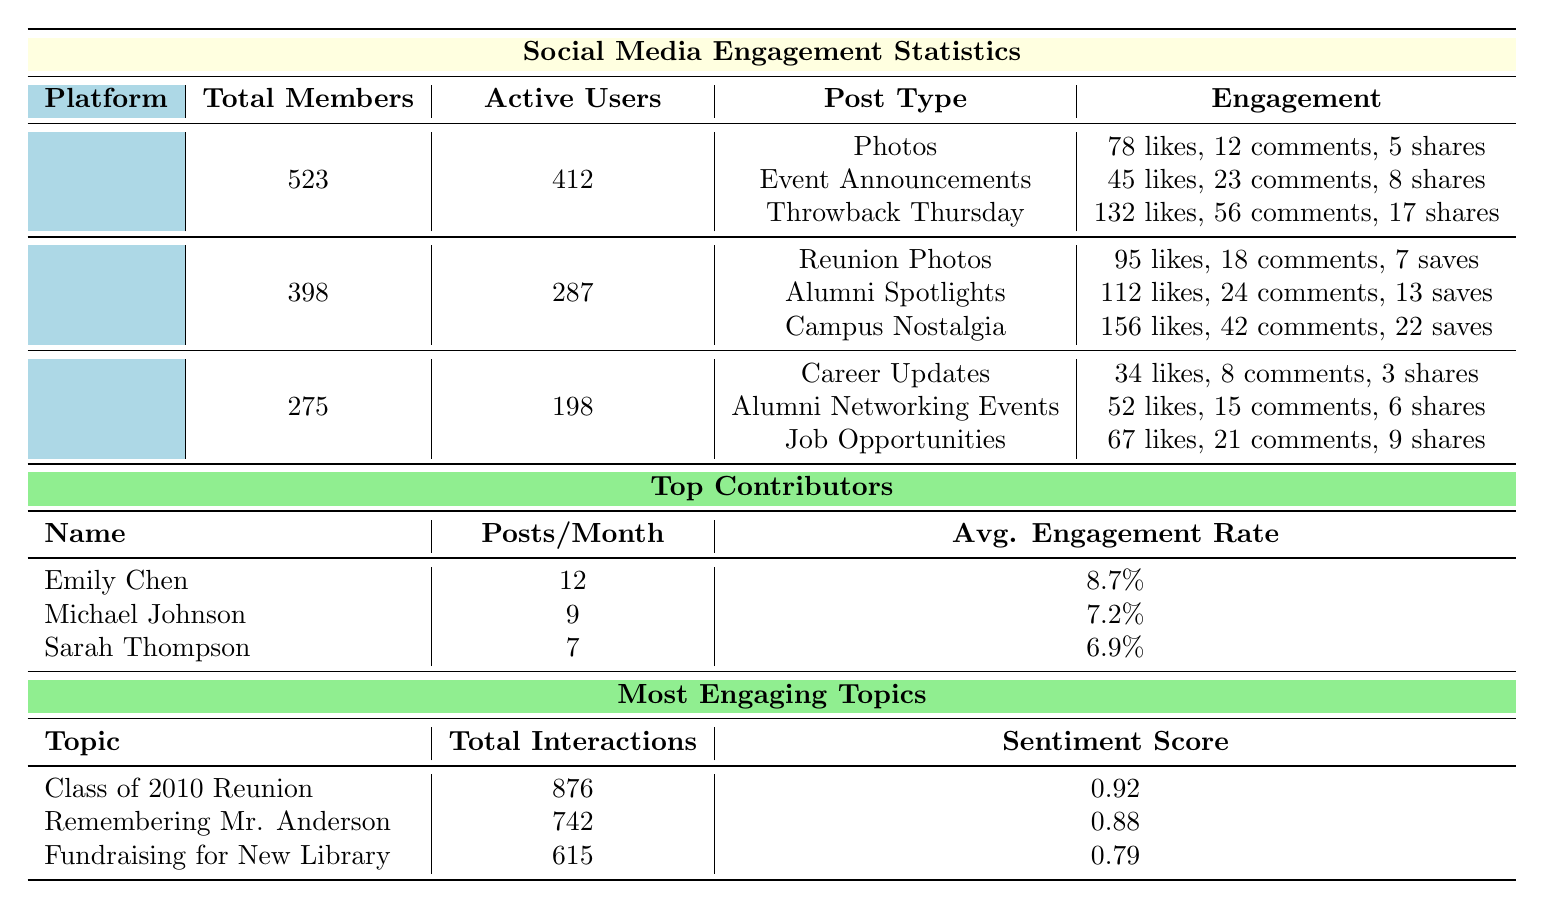What is the total number of active users on Facebook? The table states that Facebook has 412 active users listed under the column for active users.
Answer: 412 Which platform has the highest average likes for posts? By comparing the average likes across all post types, Instagram's "Campus Nostalgia" has the highest average likes at 156.
Answer: Instagram How many posts per month does Sarah Thompson make? Looking at the section for top contributors, Sarah Thompson is noted to make 7 posts per month.
Answer: 7 What is the engagement rate of Emily Chen? Emily Chen's engagement rate is listed as 8.7% in the top contributors section of the table.
Answer: 8.7% How many total interactions did the "Remembering Mr. Anderson" topic receive? In the most engaging topics section, "Remembering Mr. Anderson" shows a total of 742 interactions.
Answer: 742 What is the average number of likes for Facebook's "Throwback Thursday" posts? Under Facebook's engagement metrics, "Throwback Thursday" shows an average of 132 likes.
Answer: 132 Is the total number of interactions for the "Fundraising for New School Library" topic higher or lower than 700? The total interactions for this topic are 615, which is lower than 700.
Answer: Lower How does the average number of likes for "Job Opportunities" posts on LinkedIn compare to the average likes for "Photos" posts on Facebook? "Job Opportunities" posts have 67 likes and "Photos" posts have 78 likes on Facebook; thus, the likes for Facebook's posts are higher.
Answer: Facebook's posts are higher What is the difference in active users between Instagram and LinkedIn? Instagram has 287 active users and LinkedIn has 198. The difference is 287 - 198 = 89.
Answer: 89 Which post type generated the highest number of comments on Facebook? The "Throwback Thursday" post type received the most comments at an average of 56, compared to other types listed.
Answer: 56 